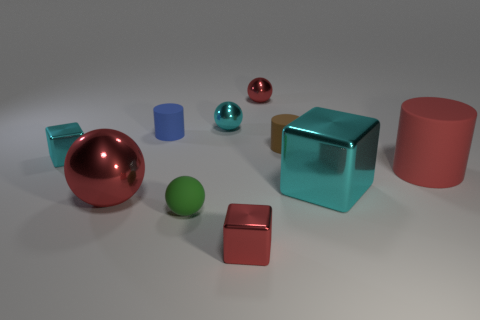The block right of the red ball right of the small blue cylinder to the right of the small cyan metal block is made of what material?
Make the answer very short. Metal. Are there the same number of red spheres that are to the right of the big cyan shiny object and tiny purple cylinders?
Offer a very short reply. Yes. Are the red cylinder that is to the right of the large cube and the small green ball in front of the blue cylinder made of the same material?
Your answer should be very brief. Yes. How many things are either large red metallic things or red metallic objects that are in front of the tiny blue rubber object?
Give a very brief answer. 2. Are there any yellow rubber objects of the same shape as the green matte thing?
Your answer should be very brief. No. What is the size of the cyan metal thing on the right side of the tiny metallic block in front of the red thing that is to the right of the brown matte cylinder?
Your answer should be very brief. Large. Are there an equal number of small metallic things in front of the tiny red metallic ball and cyan metallic things right of the brown rubber object?
Offer a very short reply. No. There is a cyan ball that is the same material as the tiny red block; what is its size?
Ensure brevity in your answer.  Small. What is the color of the small rubber sphere?
Provide a short and direct response. Green. What number of large things have the same color as the large rubber cylinder?
Your answer should be compact. 1. 